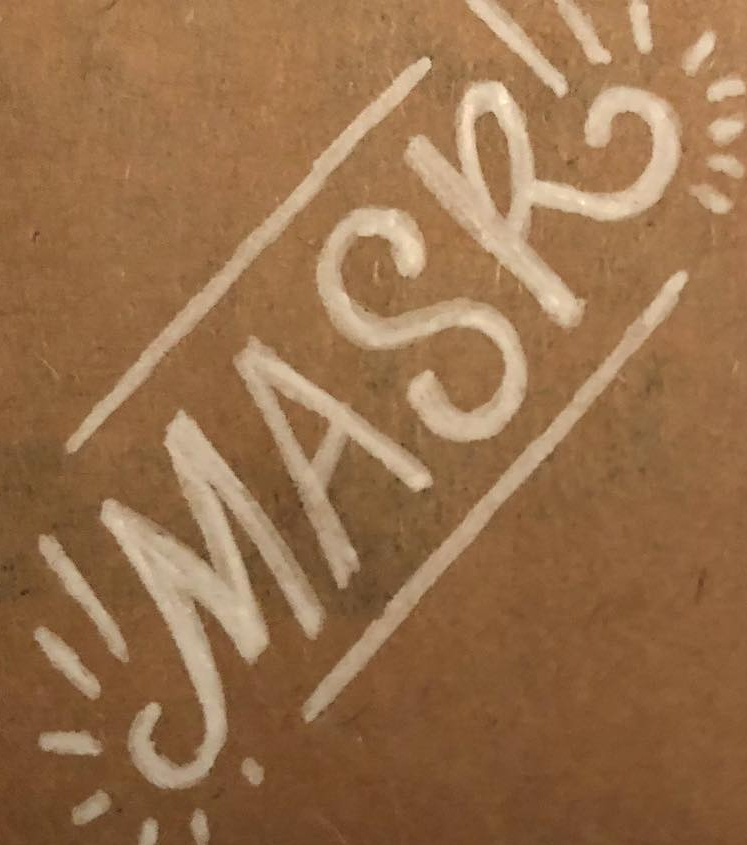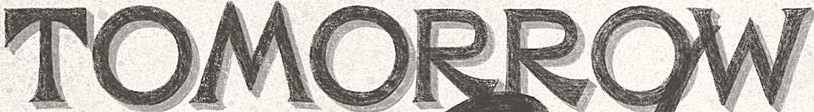What text is displayed in these images sequentially, separated by a semicolon? MASK; TOMORROW 